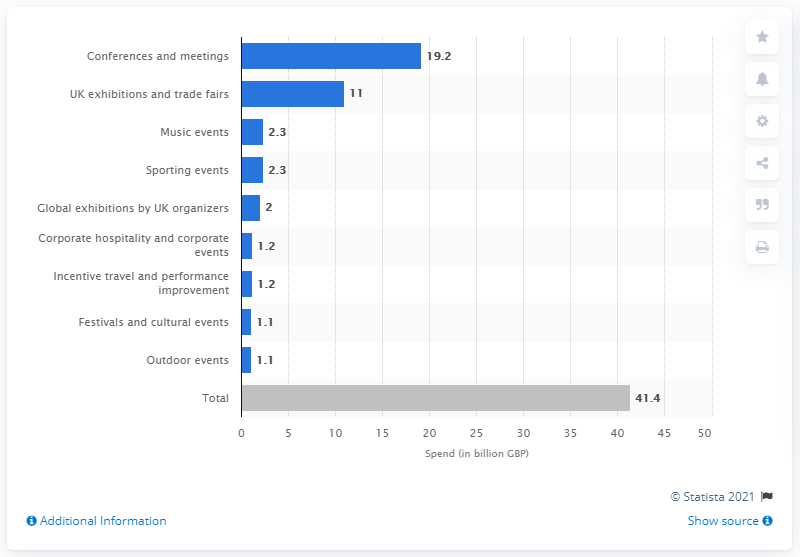Could you compare the spending on conferences and meetings to that of outdoor events? Certainly, the spending on conferences and meetings was significantly higher at 19.2 billion GBP compared to outdoor events, which saw an expenditure of 1.1 billion GBP. 